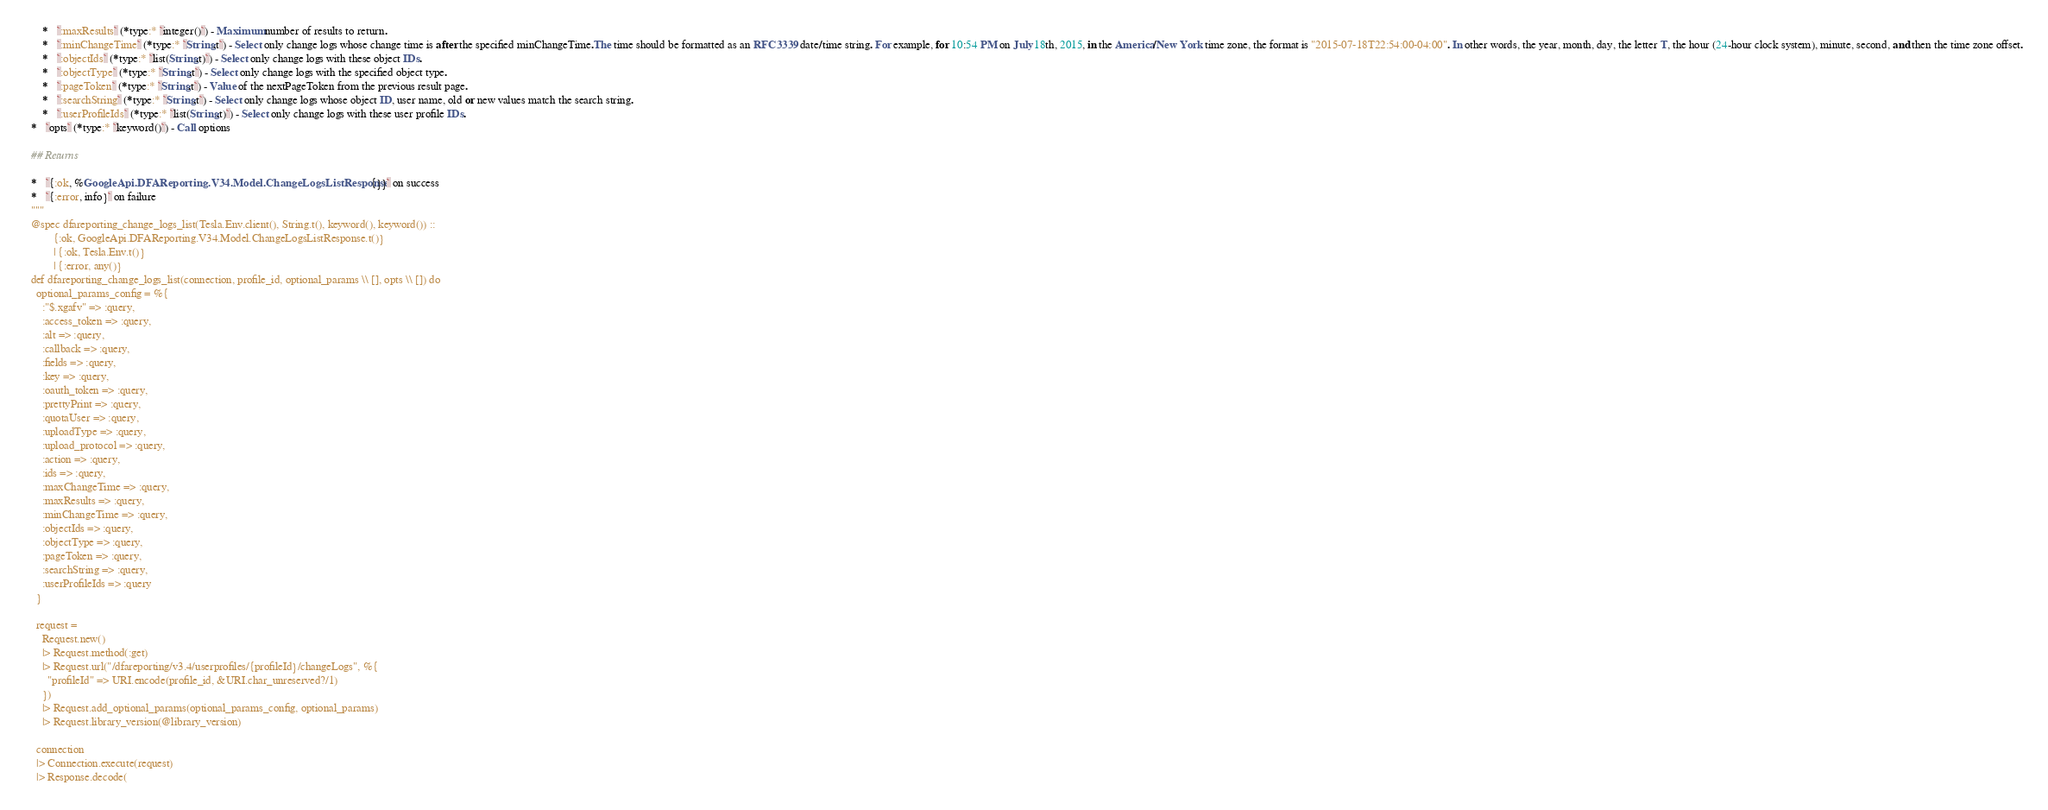<code> <loc_0><loc_0><loc_500><loc_500><_Elixir_>      *   `:maxResults` (*type:* `integer()`) - Maximum number of results to return.
      *   `:minChangeTime` (*type:* `String.t`) - Select only change logs whose change time is after the specified minChangeTime.The time should be formatted as an RFC3339 date/time string. For example, for 10:54 PM on July 18th, 2015, in the America/New York time zone, the format is "2015-07-18T22:54:00-04:00". In other words, the year, month, day, the letter T, the hour (24-hour clock system), minute, second, and then the time zone offset.
      *   `:objectIds` (*type:* `list(String.t)`) - Select only change logs with these object IDs.
      *   `:objectType` (*type:* `String.t`) - Select only change logs with the specified object type.
      *   `:pageToken` (*type:* `String.t`) - Value of the nextPageToken from the previous result page.
      *   `:searchString` (*type:* `String.t`) - Select only change logs whose object ID, user name, old or new values match the search string.
      *   `:userProfileIds` (*type:* `list(String.t)`) - Select only change logs with these user profile IDs.
  *   `opts` (*type:* `keyword()`) - Call options

  ## Returns

  *   `{:ok, %GoogleApi.DFAReporting.V34.Model.ChangeLogsListResponse{}}` on success
  *   `{:error, info}` on failure
  """
  @spec dfareporting_change_logs_list(Tesla.Env.client(), String.t(), keyword(), keyword()) ::
          {:ok, GoogleApi.DFAReporting.V34.Model.ChangeLogsListResponse.t()}
          | {:ok, Tesla.Env.t()}
          | {:error, any()}
  def dfareporting_change_logs_list(connection, profile_id, optional_params \\ [], opts \\ []) do
    optional_params_config = %{
      :"$.xgafv" => :query,
      :access_token => :query,
      :alt => :query,
      :callback => :query,
      :fields => :query,
      :key => :query,
      :oauth_token => :query,
      :prettyPrint => :query,
      :quotaUser => :query,
      :uploadType => :query,
      :upload_protocol => :query,
      :action => :query,
      :ids => :query,
      :maxChangeTime => :query,
      :maxResults => :query,
      :minChangeTime => :query,
      :objectIds => :query,
      :objectType => :query,
      :pageToken => :query,
      :searchString => :query,
      :userProfileIds => :query
    }

    request =
      Request.new()
      |> Request.method(:get)
      |> Request.url("/dfareporting/v3.4/userprofiles/{profileId}/changeLogs", %{
        "profileId" => URI.encode(profile_id, &URI.char_unreserved?/1)
      })
      |> Request.add_optional_params(optional_params_config, optional_params)
      |> Request.library_version(@library_version)

    connection
    |> Connection.execute(request)
    |> Response.decode(</code> 